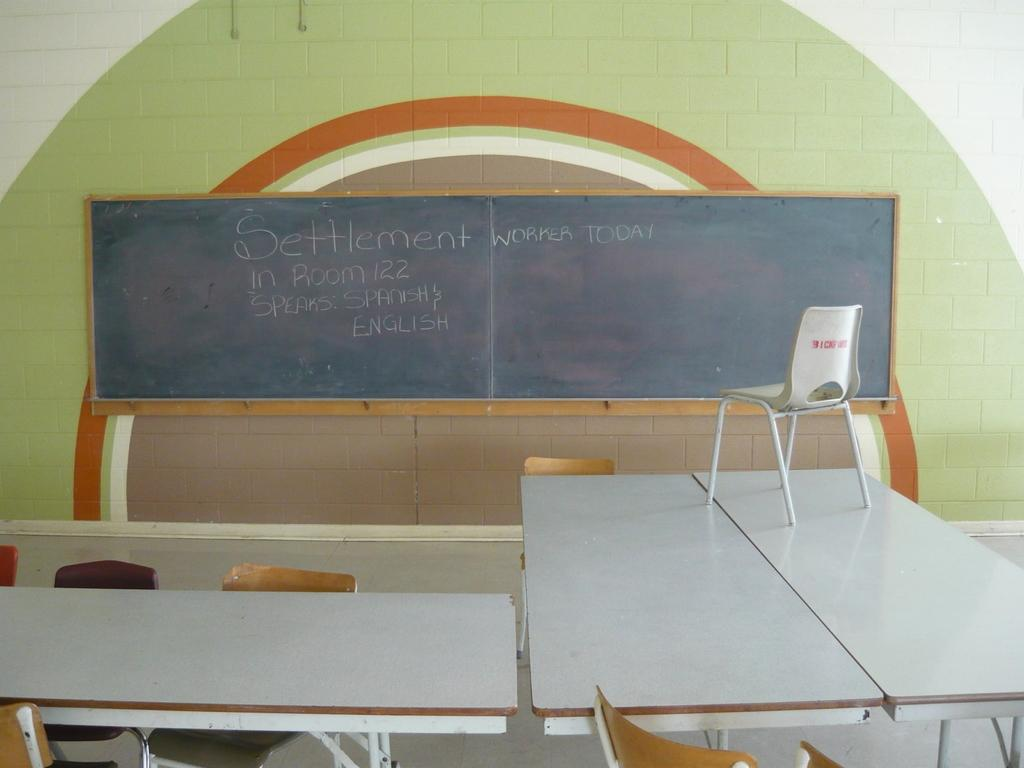Provide a one-sentence caption for the provided image. the blackboard displaying message 'settlement worker today in room 122'. 